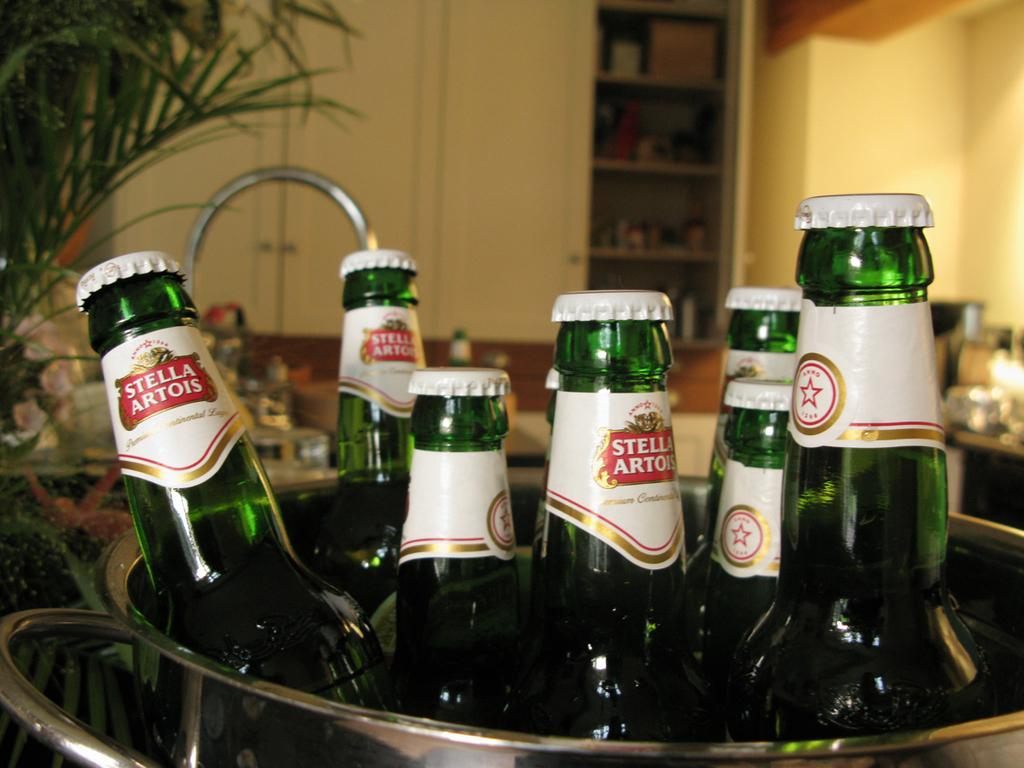<image>
Describe the image concisely. Many bottles of Stella Artois is placed inside a bucket. 